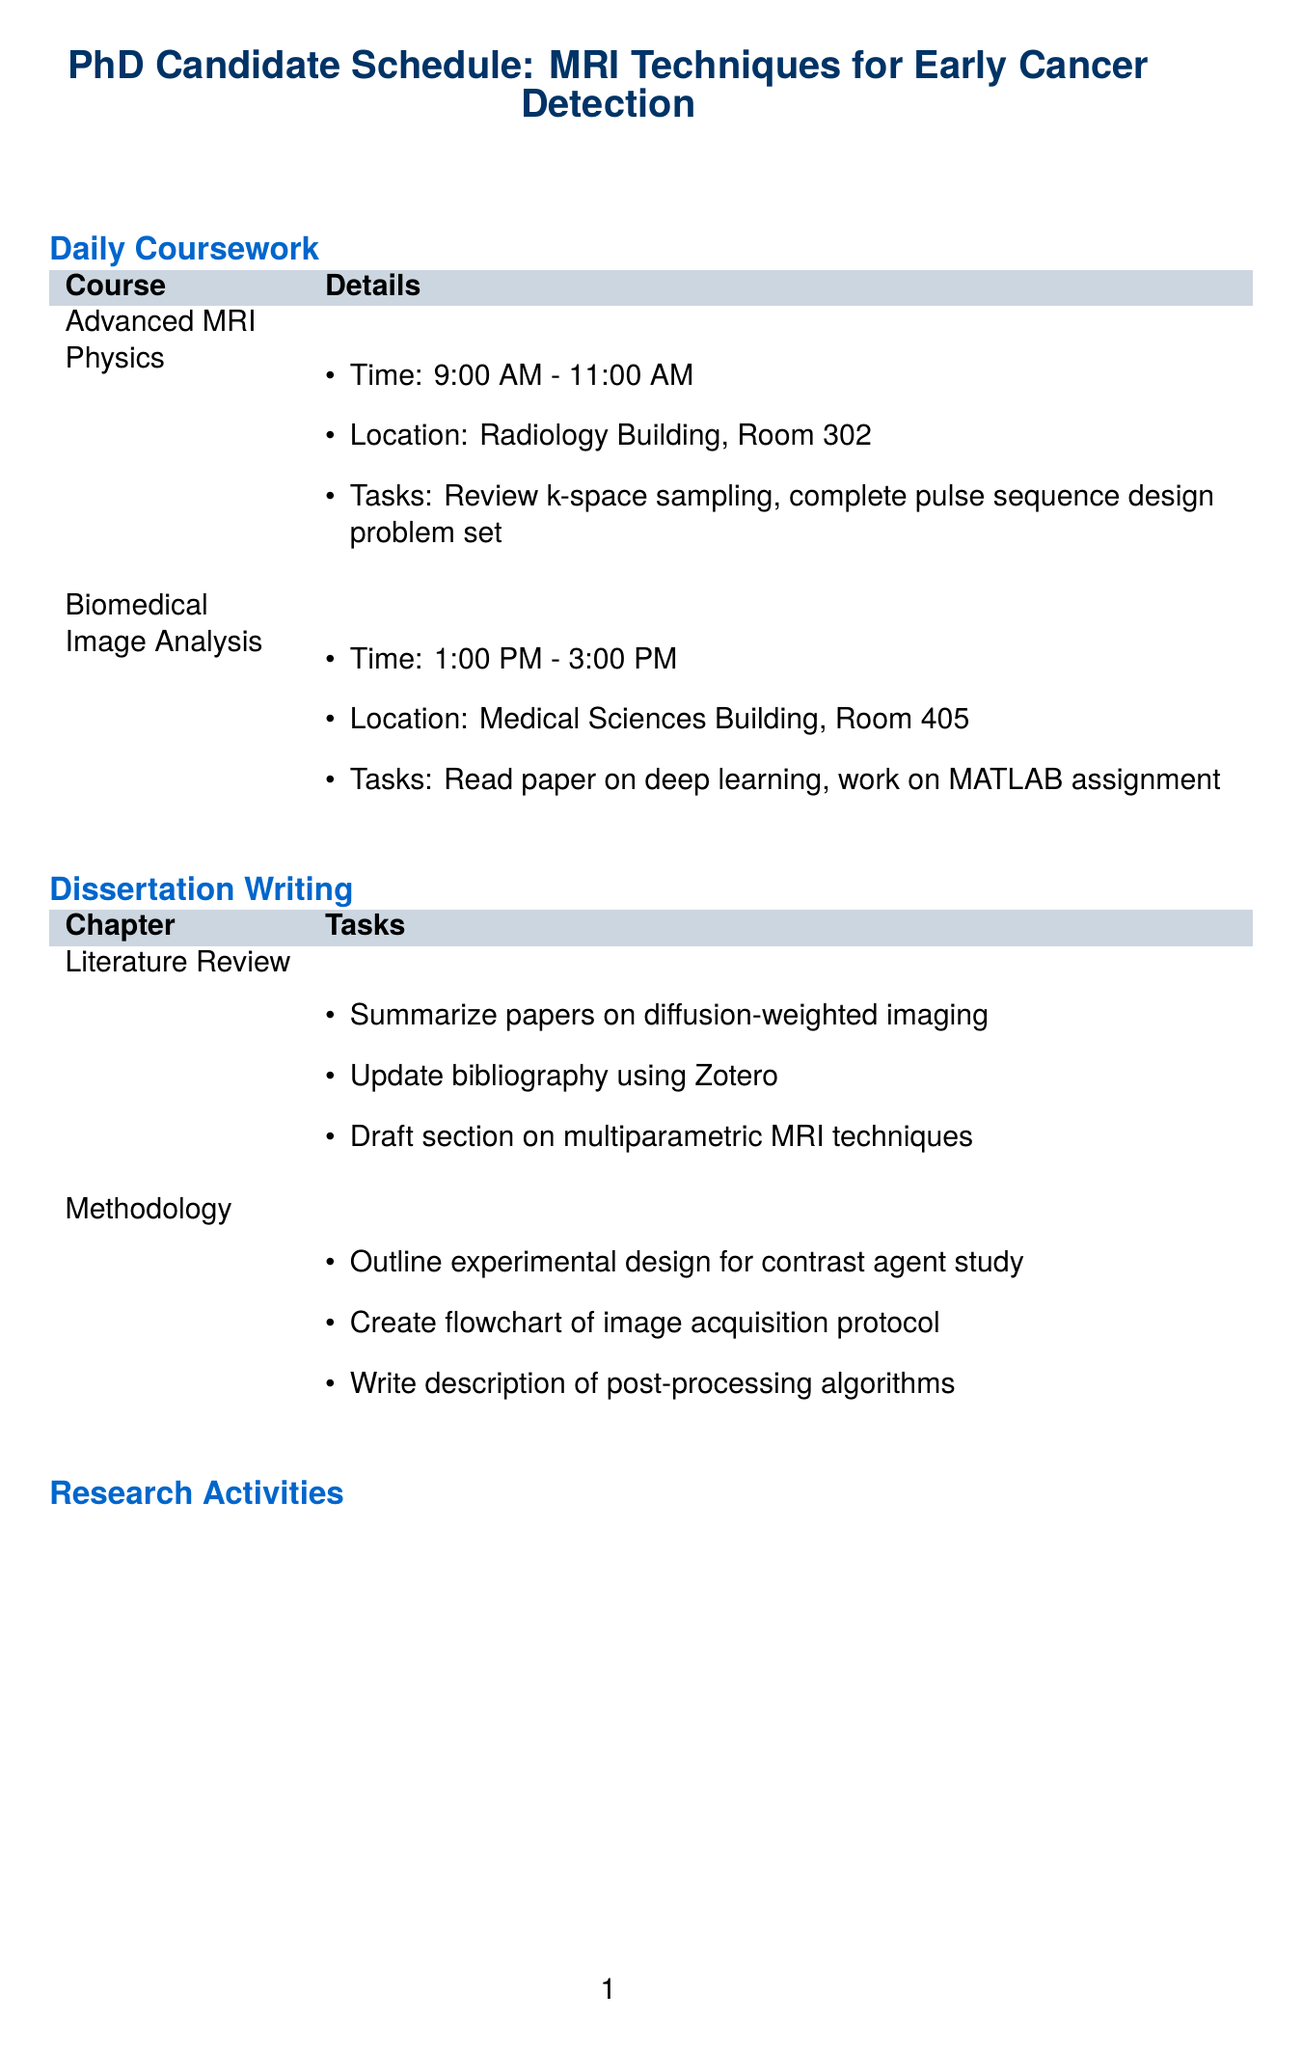What is the course name for the morning class? The course name for the morning class is found in the daily coursework section under "Advanced MRI Physics."
Answer: Advanced MRI Physics Who teaches the Biomedical Image Analysis course? The professor for Biomedical Image Analysis is listed in the daily coursework section.
Answer: Dr. Michael Chen What time does the Advanced MRI Physics class start? The start time for the Advanced MRI Physics class is specified in the daily coursework section.
Answer: 9:00 AM How many tasks are listed under the Literature Review chapter? The number of tasks for the Literature Review can be counted from the dissertation writing section.
Answer: Four What main research activity involves coordinating with the radiology department? The specific research activity is indicated in the research activities section.
Answer: Data Collection Which chapter of the dissertation includes a detailed description of post-processing algorithms? The chapter is specified in the dissertation writing section.
Answer: Methodology How many professional development activities are listed? The number of activities can be found by counting them in the professional development section.
Answer: Two What type of seminar is attended under skill enhancement? The type of seminar is described in the professional development section.
Answer: Grant writing What is a key collaboration activity mentioned in the document? The collaboration activity can be found in the collaboration and networking section.
Answer: Interdisciplinary Projects 